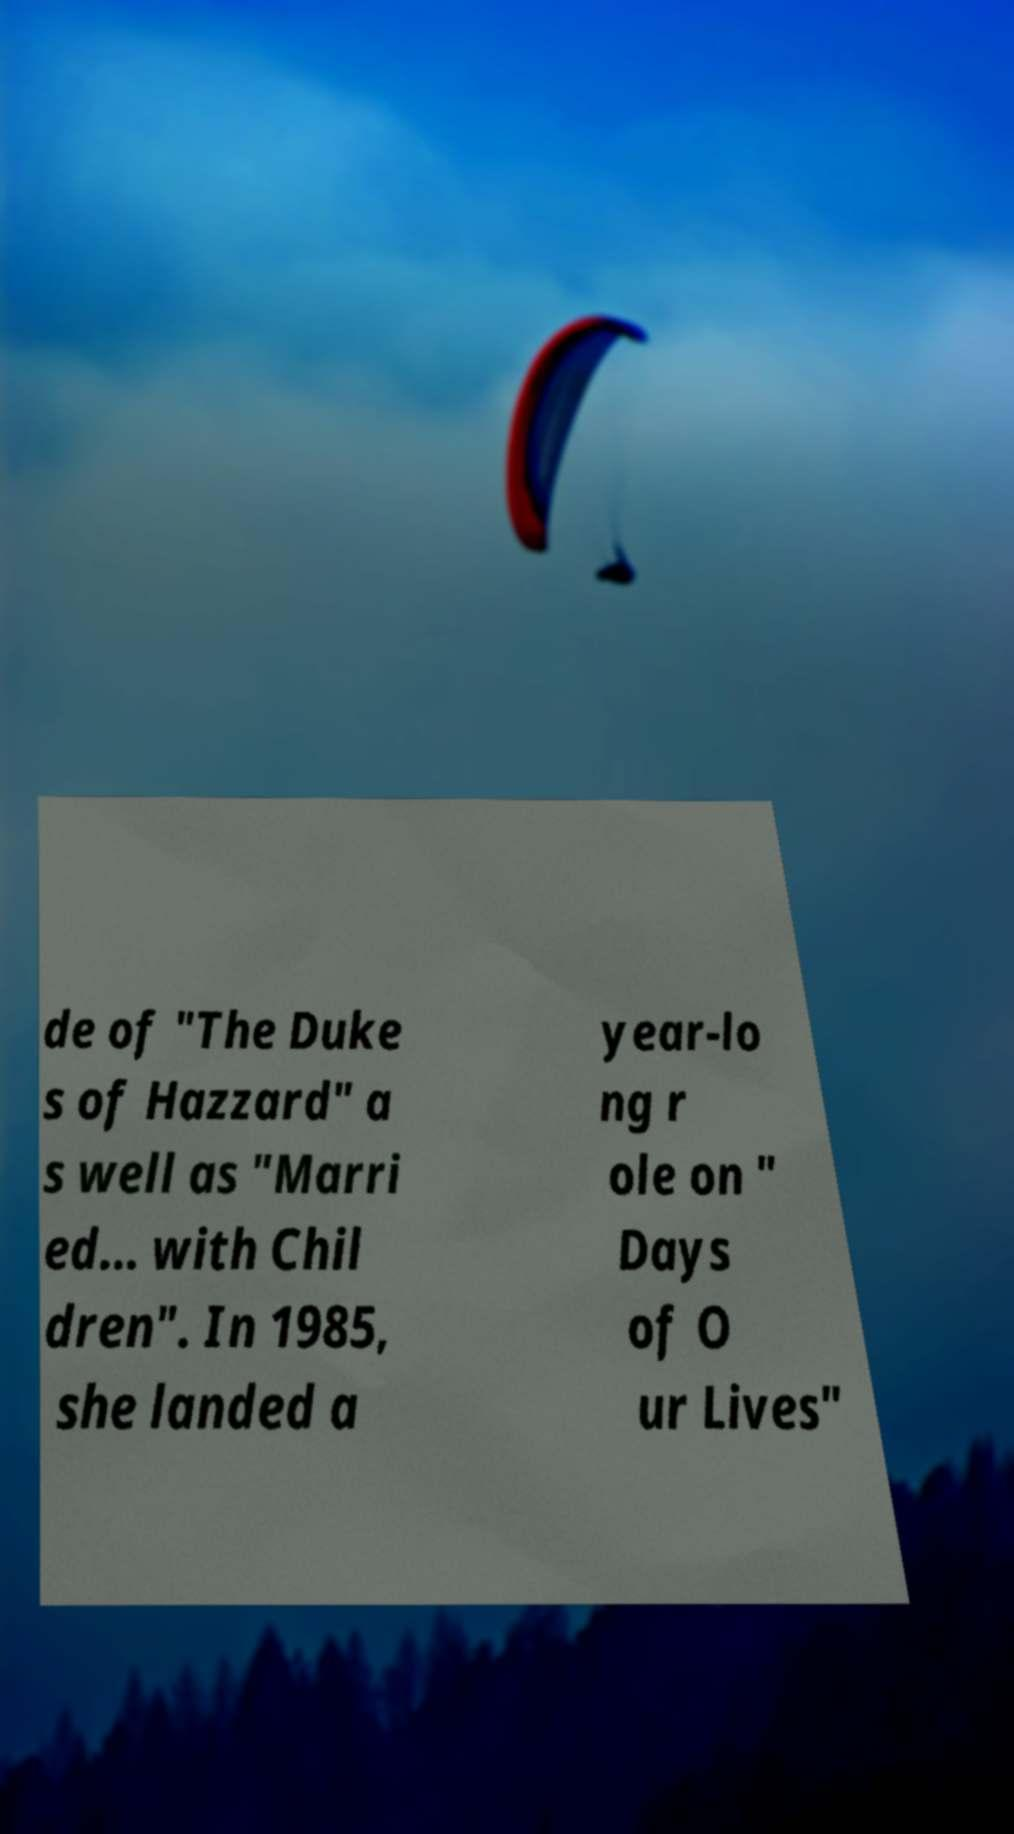Please read and relay the text visible in this image. What does it say? de of "The Duke s of Hazzard" a s well as "Marri ed... with Chil dren". In 1985, she landed a year-lo ng r ole on " Days of O ur Lives" 